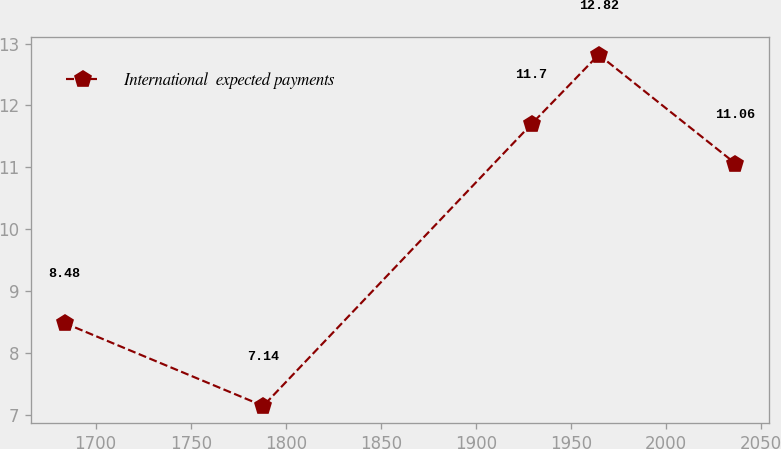Convert chart. <chart><loc_0><loc_0><loc_500><loc_500><line_chart><ecel><fcel>International  expected payments<nl><fcel>1683.62<fcel>8.48<nl><fcel>1788.15<fcel>7.14<nl><fcel>1929.32<fcel>11.7<nl><fcel>1964.61<fcel>12.82<nl><fcel>2036.52<fcel>11.06<nl></chart> 